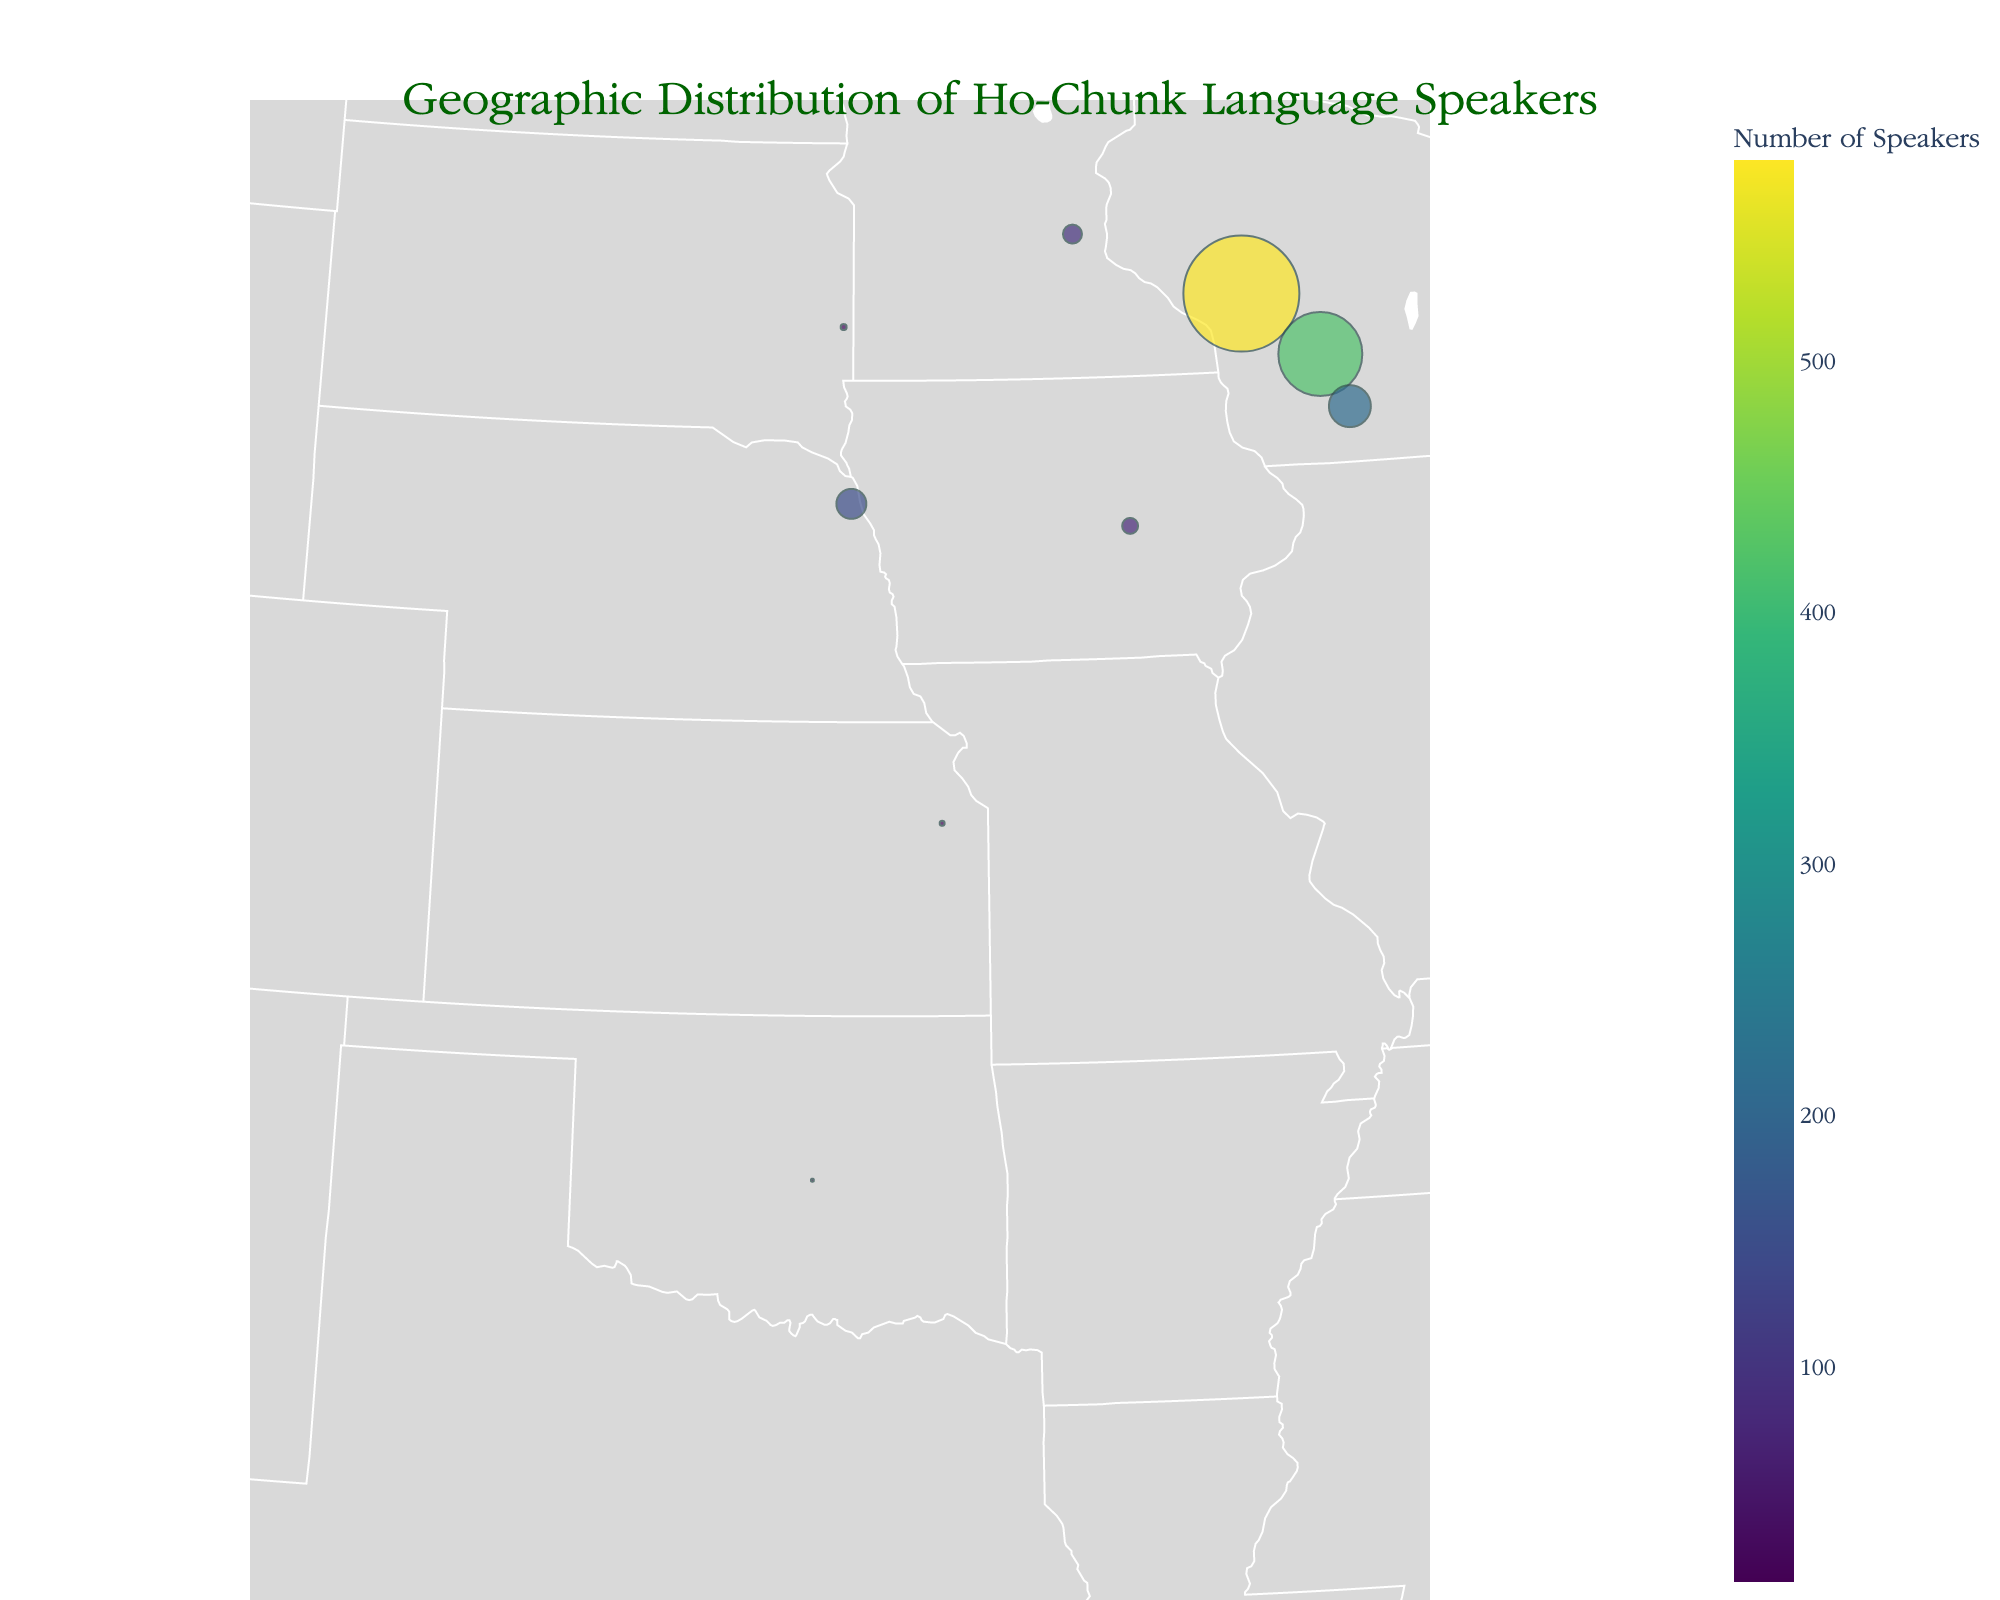Which city has the highest number of Ho-Chunk language speakers? The figure's markers vary in size according to the number of speakers. The largest marker is located in Black River Falls, Wisconsin.
Answer: Black River Falls, Wisconsin How many states have Ho-Chunk language speakers according to the figure? Count the number of distinct states listed in the data popups shown on the figure.
Answer: 7 Which city has more Ho-Chunk language speakers: Wisconsin Dells or Madison? Look at the size and color of the markers for Wisconsin Dells and Madison. Wisconsin Dells has more speakers.
Answer: Wisconsin Dells What is the total number of Ho-Chunk language speakers in Wisconsin? Add the number of speakers in Black River Falls, Wisconsin Dells, and Madison. 580 + 420 + 210 = 1210
Answer: 1210 Which city has the smallest number of Ho-Chunk language speakers? Find the city marker with the smallest size and the least intense color on the figure. This city is Shawnee, Oklahoma.
Answer: Shawnee, Oklahoma How does the number of speakers in Winnebago, Nebraska compare to that in Minneapolis, Minnesota? Check the number of speakers for each city. Winnebago has 150 speakers, while Minneapolis has 95.
Answer: Winnebago has more speakers What is the average number of Ho-Chunk language speakers across all cities shown? Add all the numbers of speakers and divide by the number of cities: (580 + 420 + 210 + 150 + 95 + 80 + 45 + 30 + 25 + 15) / 10 = 165.
Answer: 165 In which state is the city with the least number of Ho-Chunk language speakers located? Find the city with the least number of speakers (15 in Shawnee) and see which state (Oklahoma) it is located in.
Answer: Oklahoma How many Ho-Chunk language speakers are there in cities with more than 300 speakers? Add the speakers from cities with more than 300 speakers: Black River Falls and Wisconsin Dells. 580 + 420 = 1000
Answer: 1000 Is there any city outside Wisconsin with more than 100 Ho-Chunk language speakers? Check the markers for cities outside Wisconsin and their number of speakers. Only Winnebago, Nebraska has 150 speakers.
Answer: Yes 